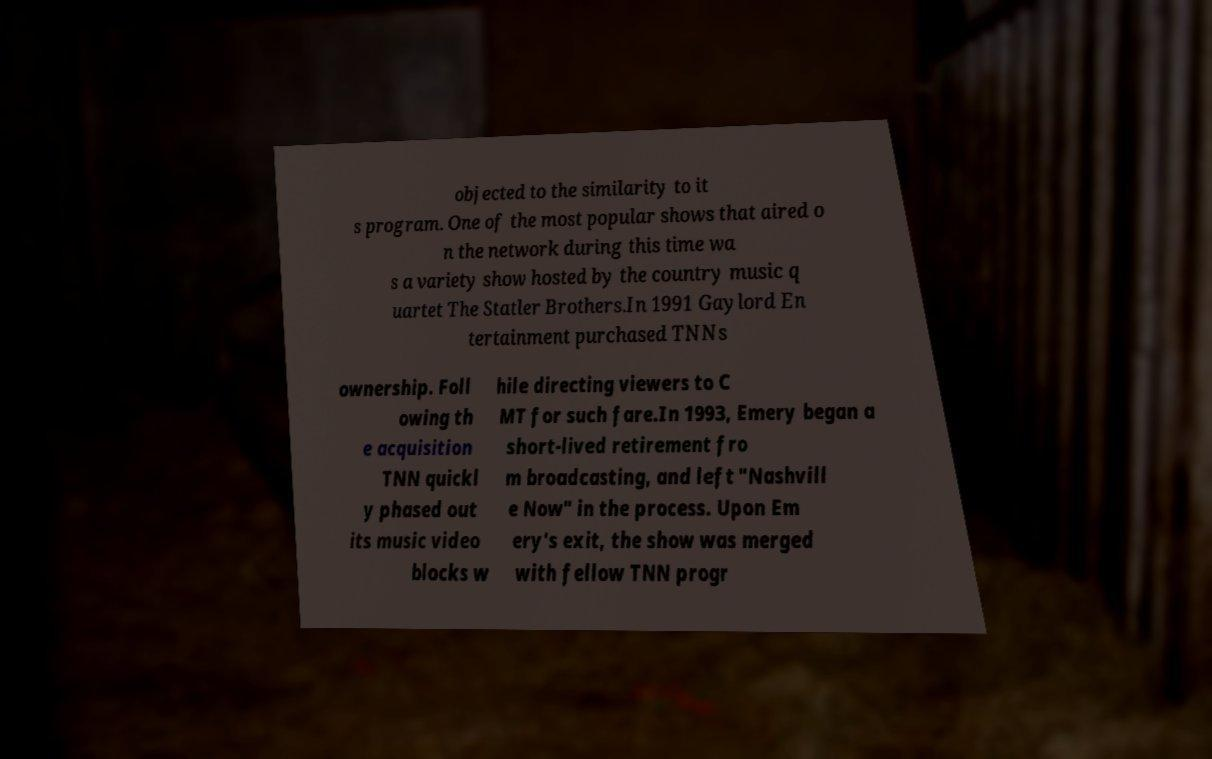Could you assist in decoding the text presented in this image and type it out clearly? objected to the similarity to it s program. One of the most popular shows that aired o n the network during this time wa s a variety show hosted by the country music q uartet The Statler Brothers.In 1991 Gaylord En tertainment purchased TNNs ownership. Foll owing th e acquisition TNN quickl y phased out its music video blocks w hile directing viewers to C MT for such fare.In 1993, Emery began a short-lived retirement fro m broadcasting, and left "Nashvill e Now" in the process. Upon Em ery's exit, the show was merged with fellow TNN progr 